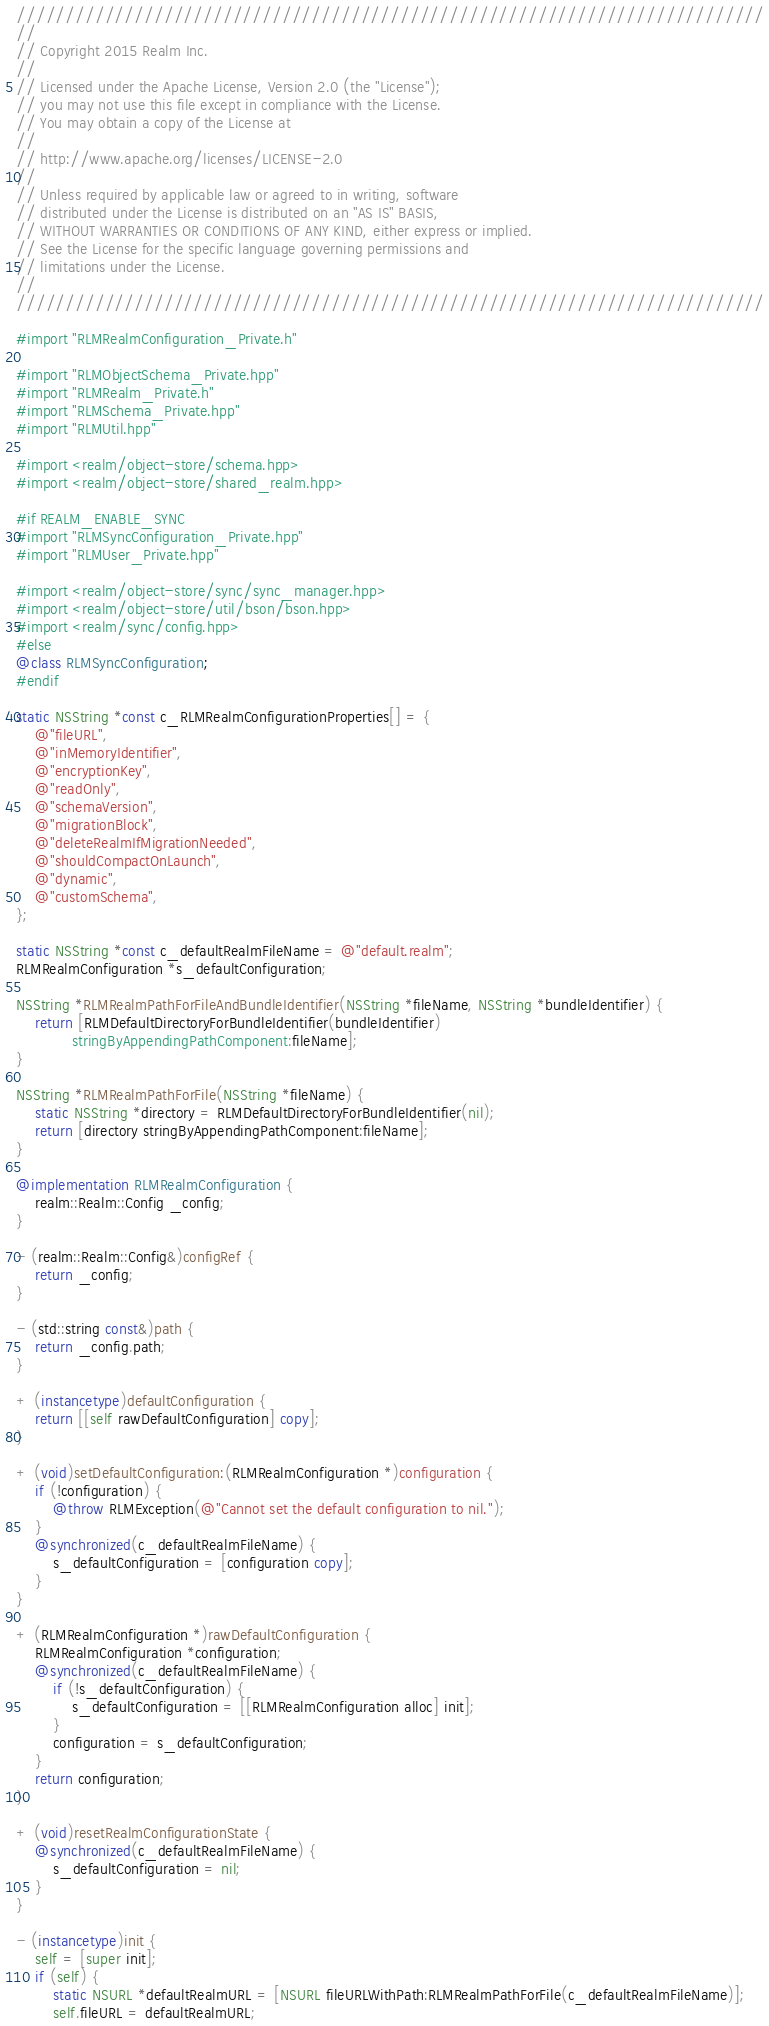Convert code to text. <code><loc_0><loc_0><loc_500><loc_500><_ObjectiveC_>////////////////////////////////////////////////////////////////////////////
//
// Copyright 2015 Realm Inc.
//
// Licensed under the Apache License, Version 2.0 (the "License");
// you may not use this file except in compliance with the License.
// You may obtain a copy of the License at
//
// http://www.apache.org/licenses/LICENSE-2.0
//
// Unless required by applicable law or agreed to in writing, software
// distributed under the License is distributed on an "AS IS" BASIS,
// WITHOUT WARRANTIES OR CONDITIONS OF ANY KIND, either express or implied.
// See the License for the specific language governing permissions and
// limitations under the License.
//
////////////////////////////////////////////////////////////////////////////

#import "RLMRealmConfiguration_Private.h"

#import "RLMObjectSchema_Private.hpp"
#import "RLMRealm_Private.h"
#import "RLMSchema_Private.hpp"
#import "RLMUtil.hpp"

#import <realm/object-store/schema.hpp>
#import <realm/object-store/shared_realm.hpp>

#if REALM_ENABLE_SYNC
#import "RLMSyncConfiguration_Private.hpp"
#import "RLMUser_Private.hpp"

#import <realm/object-store/sync/sync_manager.hpp>
#import <realm/object-store/util/bson/bson.hpp>
#import <realm/sync/config.hpp>
#else
@class RLMSyncConfiguration;
#endif

static NSString *const c_RLMRealmConfigurationProperties[] = {
    @"fileURL",
    @"inMemoryIdentifier",
    @"encryptionKey",
    @"readOnly",
    @"schemaVersion",
    @"migrationBlock",
    @"deleteRealmIfMigrationNeeded",
    @"shouldCompactOnLaunch",
    @"dynamic",
    @"customSchema",
};

static NSString *const c_defaultRealmFileName = @"default.realm";
RLMRealmConfiguration *s_defaultConfiguration;

NSString *RLMRealmPathForFileAndBundleIdentifier(NSString *fileName, NSString *bundleIdentifier) {
    return [RLMDefaultDirectoryForBundleIdentifier(bundleIdentifier)
            stringByAppendingPathComponent:fileName];
}

NSString *RLMRealmPathForFile(NSString *fileName) {
    static NSString *directory = RLMDefaultDirectoryForBundleIdentifier(nil);
    return [directory stringByAppendingPathComponent:fileName];
}

@implementation RLMRealmConfiguration {
    realm::Realm::Config _config;
}

- (realm::Realm::Config&)configRef {
    return _config;
}

- (std::string const&)path {
    return _config.path;
}

+ (instancetype)defaultConfiguration {
    return [[self rawDefaultConfiguration] copy];
}

+ (void)setDefaultConfiguration:(RLMRealmConfiguration *)configuration {
    if (!configuration) {
        @throw RLMException(@"Cannot set the default configuration to nil.");
    }
    @synchronized(c_defaultRealmFileName) {
        s_defaultConfiguration = [configuration copy];
    }
}

+ (RLMRealmConfiguration *)rawDefaultConfiguration {
    RLMRealmConfiguration *configuration;
    @synchronized(c_defaultRealmFileName) {
        if (!s_defaultConfiguration) {
            s_defaultConfiguration = [[RLMRealmConfiguration alloc] init];
        }
        configuration = s_defaultConfiguration;
    }
    return configuration;
}

+ (void)resetRealmConfigurationState {
    @synchronized(c_defaultRealmFileName) {
        s_defaultConfiguration = nil;
    }
}

- (instancetype)init {
    self = [super init];
    if (self) {
        static NSURL *defaultRealmURL = [NSURL fileURLWithPath:RLMRealmPathForFile(c_defaultRealmFileName)];
        self.fileURL = defaultRealmURL;</code> 